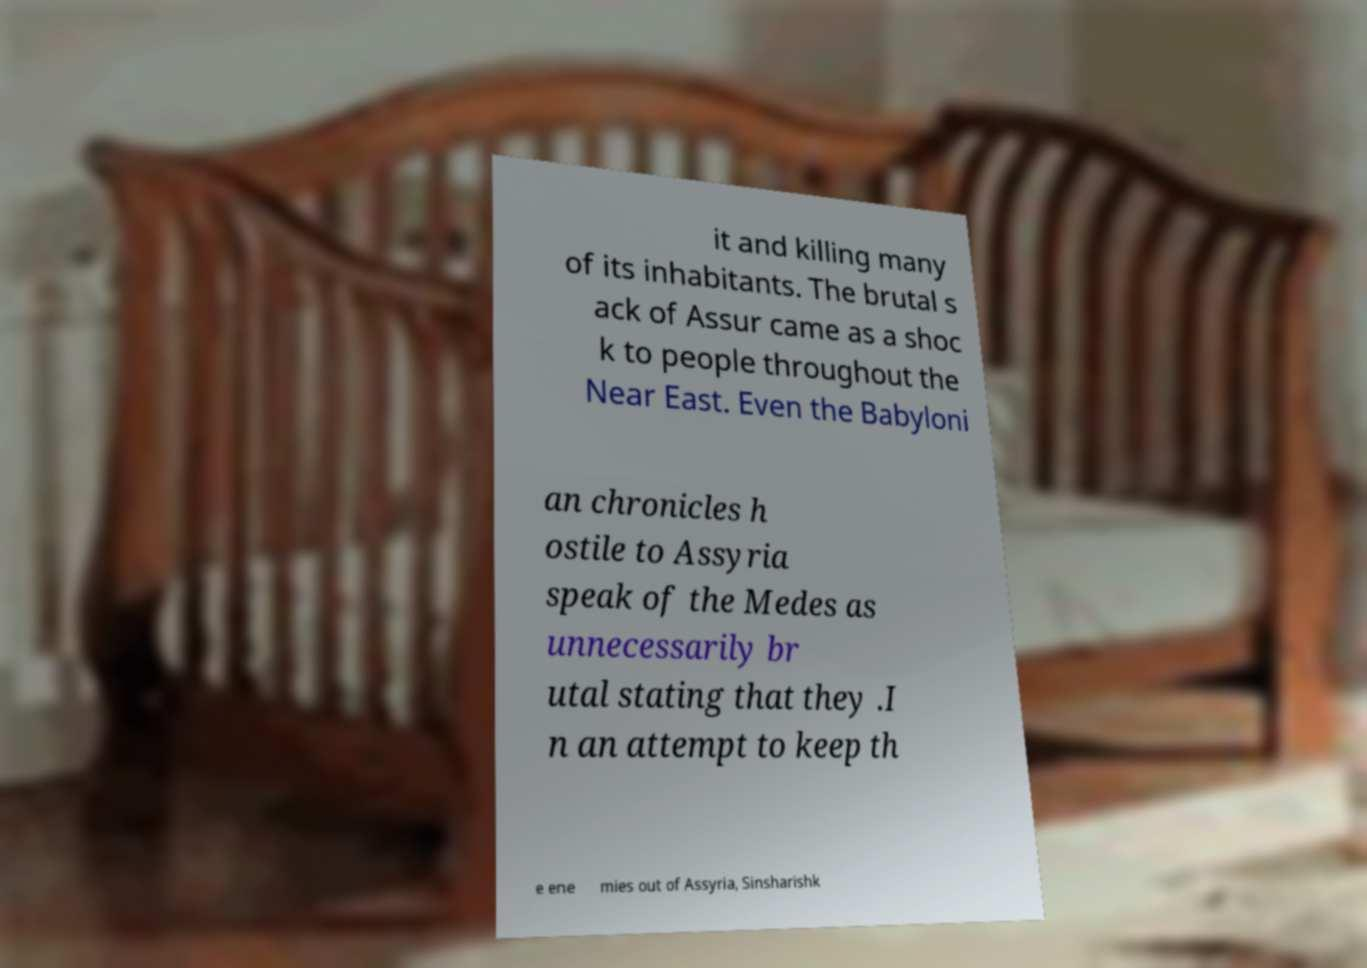Could you assist in decoding the text presented in this image and type it out clearly? it and killing many of its inhabitants. The brutal s ack of Assur came as a shoc k to people throughout the Near East. Even the Babyloni an chronicles h ostile to Assyria speak of the Medes as unnecessarily br utal stating that they .I n an attempt to keep th e ene mies out of Assyria, Sinsharishk 